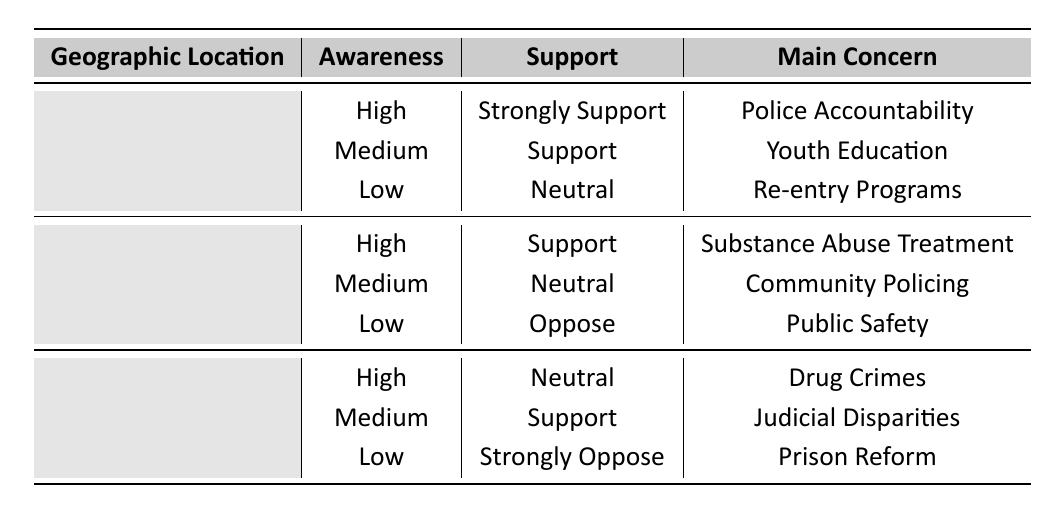What is the main concern for the support for reform in urban areas with medium awareness? The table shows that for Urban areas with Medium awareness, the support for reform is categorized as "Support," and the main concern listed is "Youth Education."
Answer: Youth Education How many support categories are there for suburban areas? The table lists three support categories for Suburban areas: High (Support), Medium (Neutral), and Low (Oppose). Therefore, there are three distinct support categories represented.
Answer: 3 Is there any geographic location where the support for reform is categorized as "Strongly Support"? Referring to the Urban area, it shows that the awareness is High and the support for reform is categorized as "Strongly Support." Therefore, the answer is yes, it exists in Urban areas.
Answer: Yes What is the difference in support for reform between Low awareness in Urban and Rural areas? For Urban areas with Low awareness, support for reform is "Neutral." For Rural areas with Low awareness, support is "Strongly Oppose." The difference is that "Neutral" is less supportive than "Strongly Oppose." Hence, the Urban area is more favorable.
Answer: Urban is more favorable Which geographic location has the highest awareness category, and what is their main concern? The table shows that all three geographic locations have a High awareness category. For Urban, the main concern is "Police Accountability." For Suburban, it is "Substance Abuse Treatment." For Rural, it is "Drug Crimes." Each location's highest awareness category has different main concerns.
Answer: Varies by location How many areas have a support level of "Neutral" and what are their awareness levels? The table indicates two areas with "Neutral" support: Urban (Low awareness) and Rural (High awareness). So, there are two areas with a "Neutral" support level.
Answer: 2 areas What is the range of support levels found in the data table? The support levels in the data are "Strongly Support," "Support," "Neutral," "Oppose," and "Strongly Oppose." By identifying these categories, the range consists of five distinct support levels from strong endorsement to strong disagreement.
Answer: 5 levels In which geographic area do we see a "Support" level in the context with "Medium" awareness? The table indicates that in Rural areas with Medium awareness, the support level is "Support." Therefore, the geographic area where this occurs is Rural.
Answer: Rural 